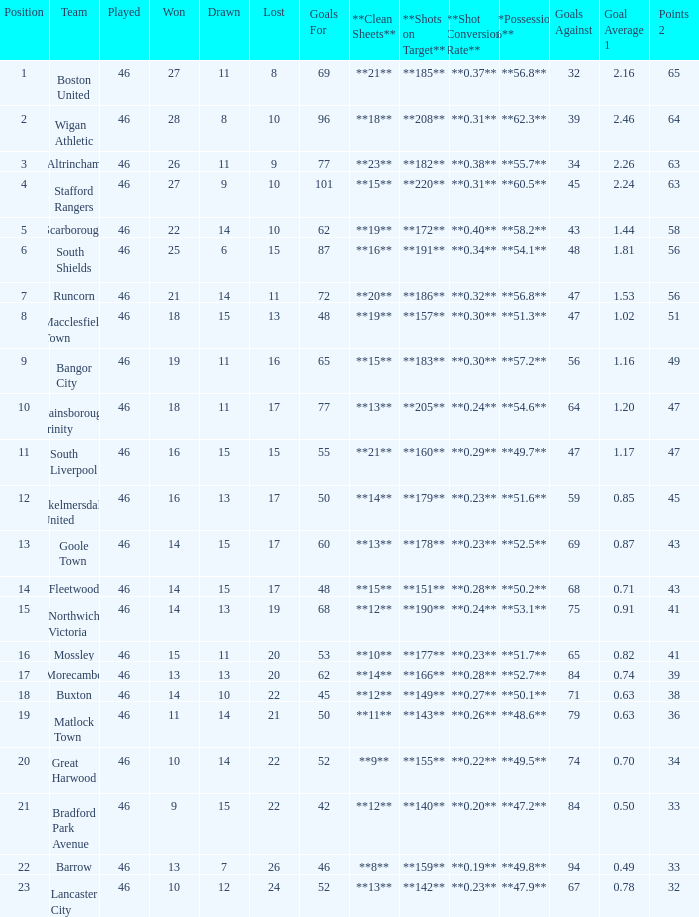How many points did Goole Town accumulate? 1.0. 